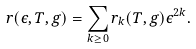<formula> <loc_0><loc_0><loc_500><loc_500>r ( \epsilon , T , g ) = \sum _ { k \geq 0 } r _ { k } ( T , g ) \epsilon ^ { 2 k } .</formula> 